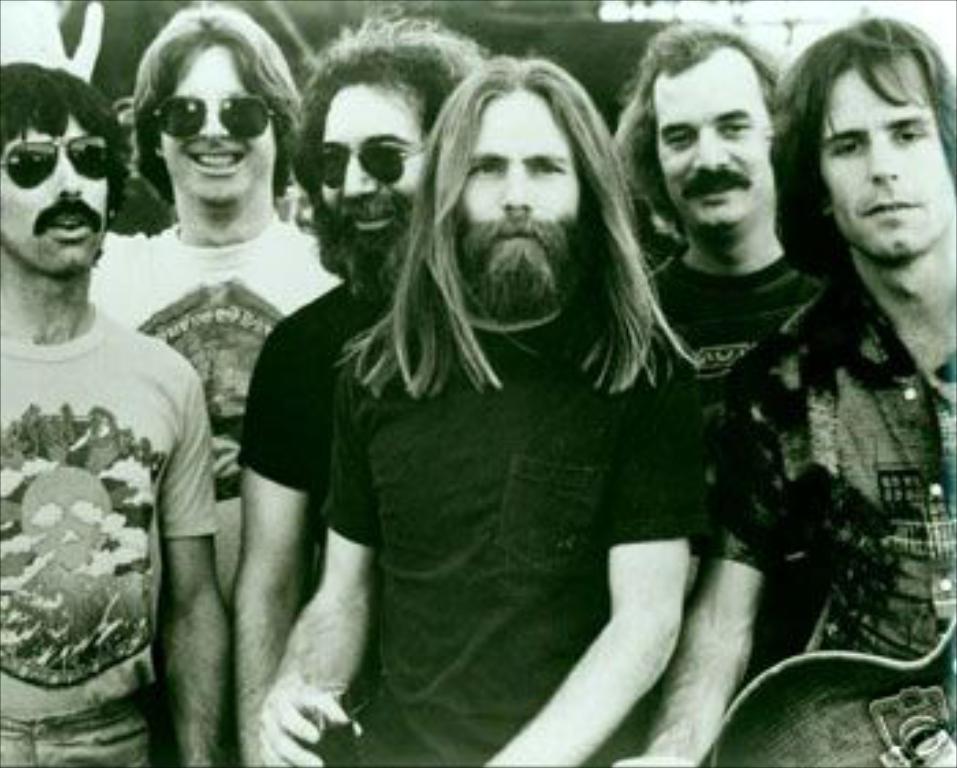Please provide a concise description of this image. In this picture I can see a group of men are there, they are wearing t-shirts. On the left side three men are wearing goggles. 